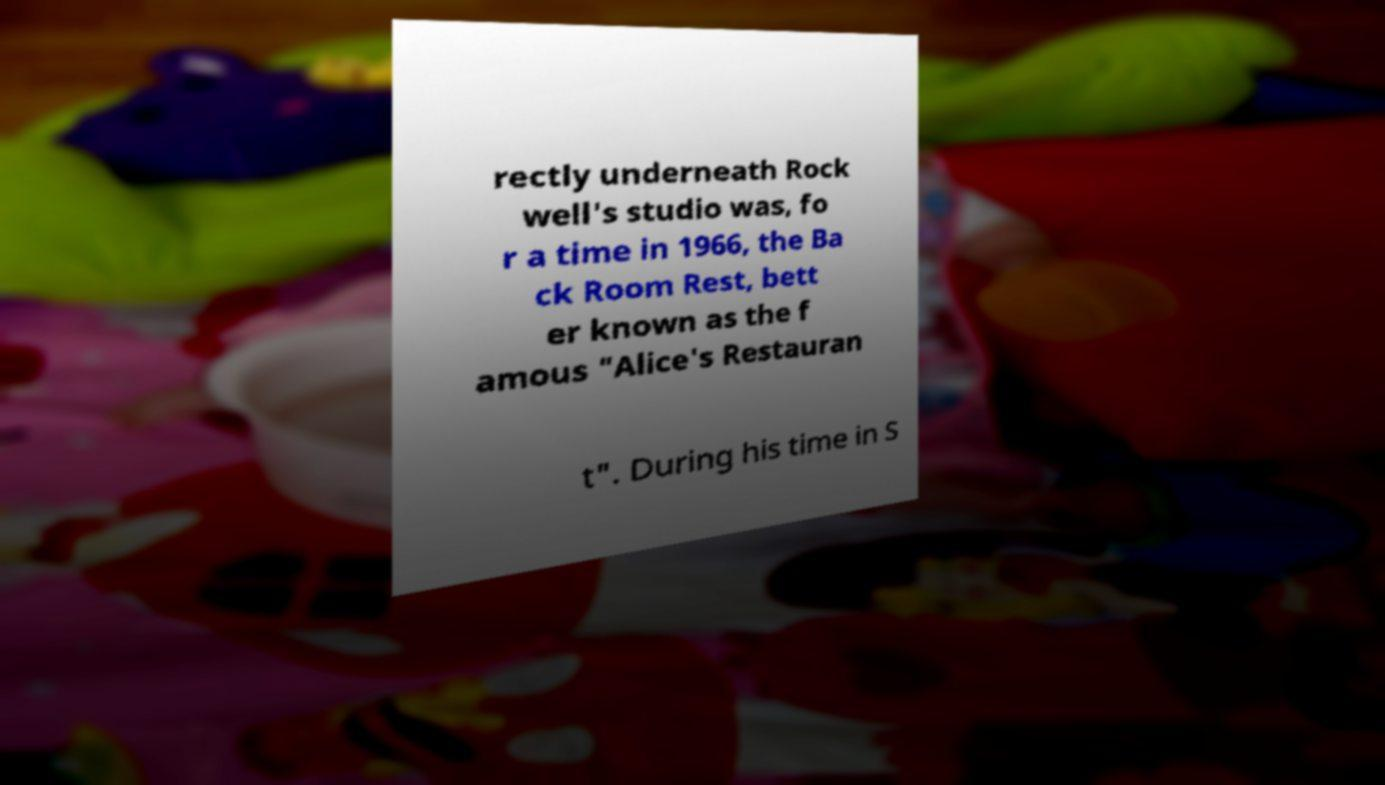Please identify and transcribe the text found in this image. rectly underneath Rock well's studio was, fo r a time in 1966, the Ba ck Room Rest, bett er known as the f amous "Alice's Restauran t". During his time in S 